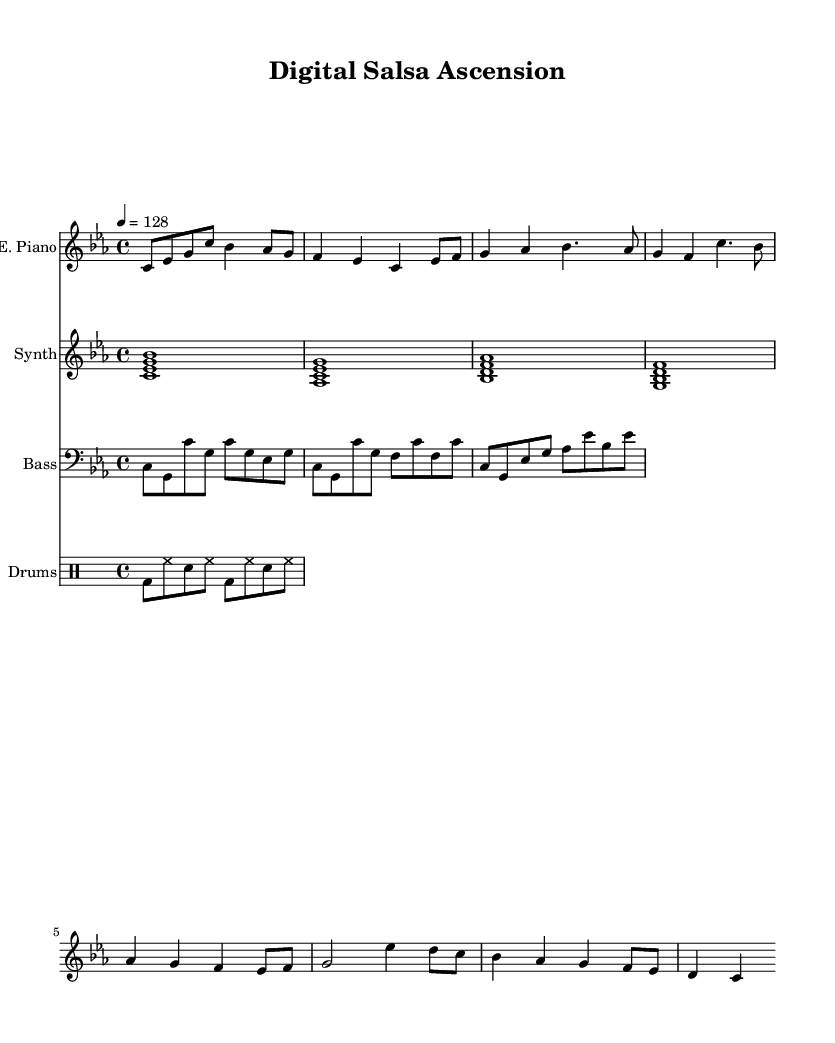What is the key signature of this music? The key signature shown in the beginning of the staff is C minor, which has three flats (B flat, E flat, and A flat).
Answer: C minor What is the time signature? The time signature noted at the beginning of the piece shows four beats per measure, indicated by 4 over 4.
Answer: 4/4 What is the tempo marking? The tempo marking indicates the speed of the piece, which is set at 128 beats per minute, shown under the tempo directive.
Answer: 128 How many measures are in the verse section? The verse section consists of two lines of music, each containing four measures, totaling eight measures.
Answer: 8 What instruments are involved in this piece? The score specifies four instrumental parts: electric piano, synth, bass, and drums, as noted in the staff names.
Answer: Electric piano, synth, bass, drums What musical elements signify the Latin influence in this composition? The presence of syncopated rhythms typical in salsa music along with the instrumentation suggests a Latin influence in the music style.
Answer: Syncopated rhythms What is the relationship between the electric piano and the bass throughout the piece? The electric piano plays a melodic line while the bass provides a rhythmic foundation, working together to create a harmonic texture that supports the piano.
Answer: Complementary 